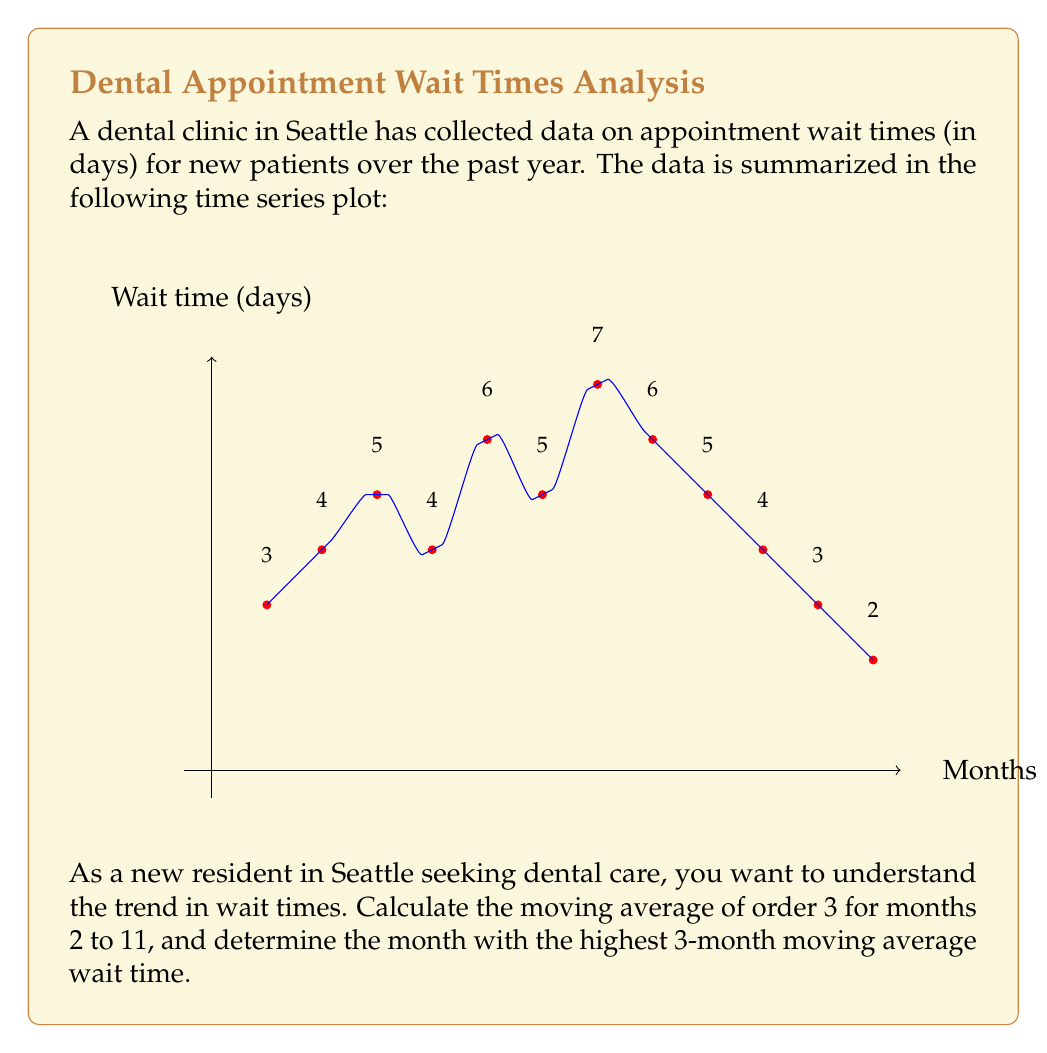Could you help me with this problem? To solve this problem, we'll follow these steps:

1) First, let's recall the formula for a moving average of order 3:

   $$MA_3(t) = \frac{Y_{t-1} + Y_t + Y_{t+1}}{3}$$

   where $Y_t$ is the value at time $t$.

2) Now, let's calculate the 3-month moving average for months 2 to 11:

   Month 2: $MA_3(2) = \frac{3 + 4 + 5}{3} = 4$
   Month 3: $MA_3(3) = \frac{4 + 5 + 4}{3} = 4.33$
   Month 4: $MA_3(4) = \frac{5 + 4 + 6}{3} = 5$
   Month 5: $MA_3(5) = \frac{4 + 6 + 5}{3} = 5$
   Month 6: $MA_3(6) = \frac{6 + 5 + 7}{3} = 6$
   Month 7: $MA_3(7) = \frac{5 + 7 + 6}{3} = 6$
   Month 8: $MA_3(8) = \frac{7 + 6 + 5}{3} = 6$
   Month 9: $MA_3(9) = \frac{6 + 5 + 4}{3} = 5$
   Month 10: $MA_3(10) = \frac{5 + 4 + 3}{3} = 4$
   Month 11: $MA_3(11) = \frac{4 + 3 + 2}{3} = 3$

3) Looking at these results, we can see that the highest 3-month moving average is 6, which occurs in months 6, 7, and 8.

4) Among these, month 6 is the earliest occurrence of the highest moving average.

Therefore, month 6 has the highest 3-month moving average wait time.
Answer: Month 6 